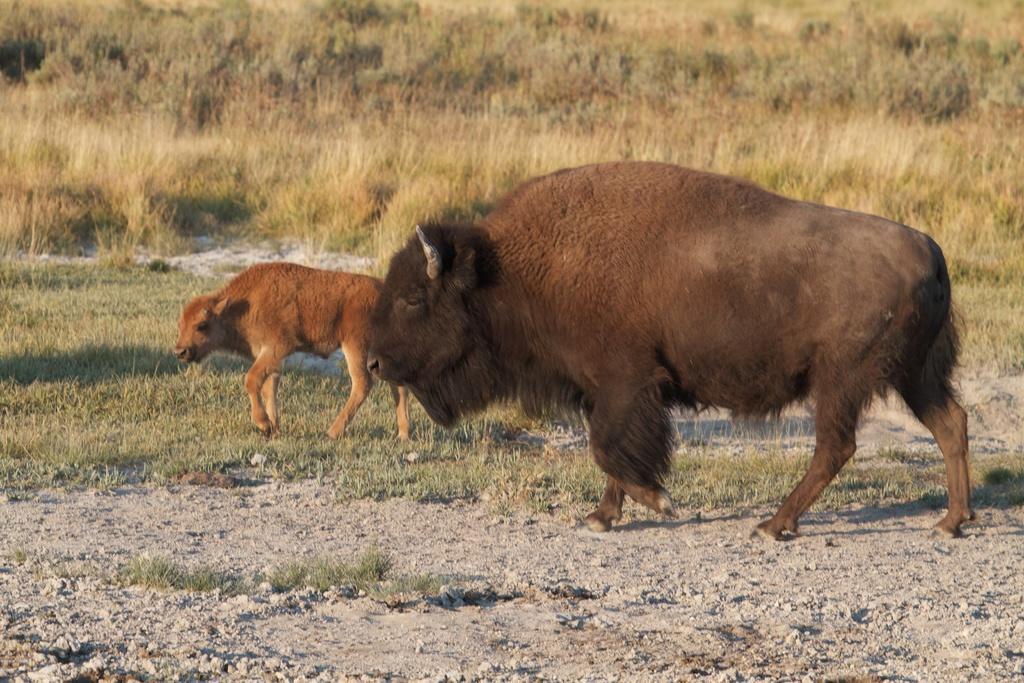Describe this image in one or two sentences. In this image I can see two animals, they are in brown and cream color. Background I can see the trees and grass in green color. 